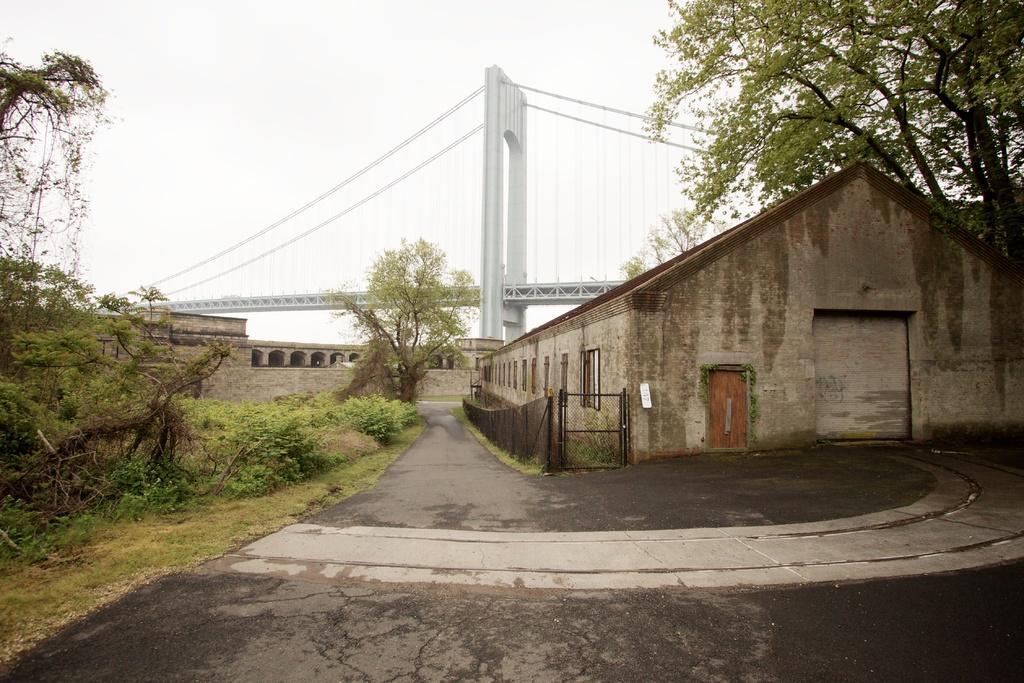How would you summarize this image in a sentence or two? In this image on the left side there are trees, plants and there's grass on the ground. On the right side there is a shed and there are trees. In the background there is a tree, there is monument and there is a bridge. 